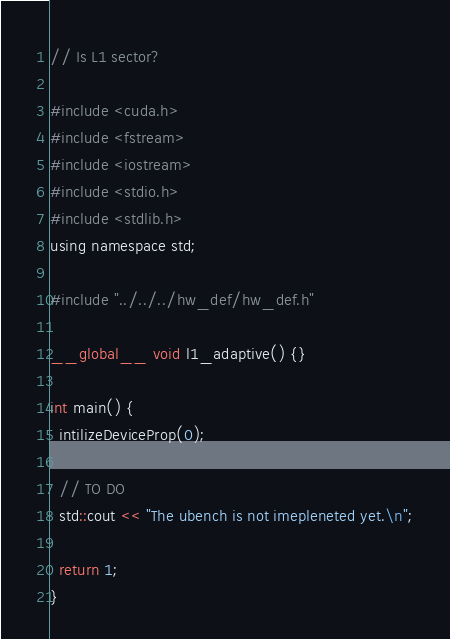<code> <loc_0><loc_0><loc_500><loc_500><_Cuda_>// Is L1 sector?

#include <cuda.h>
#include <fstream>
#include <iostream>
#include <stdio.h>
#include <stdlib.h>
using namespace std;

#include "../../../hw_def/hw_def.h"

__global__ void l1_adaptive() {}

int main() {
  intilizeDeviceProp(0);

  // TO DO
  std::cout << "The ubench is not imepleneted yet.\n";

  return 1;
}
</code> 